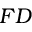Convert formula to latex. <formula><loc_0><loc_0><loc_500><loc_500>F D</formula> 